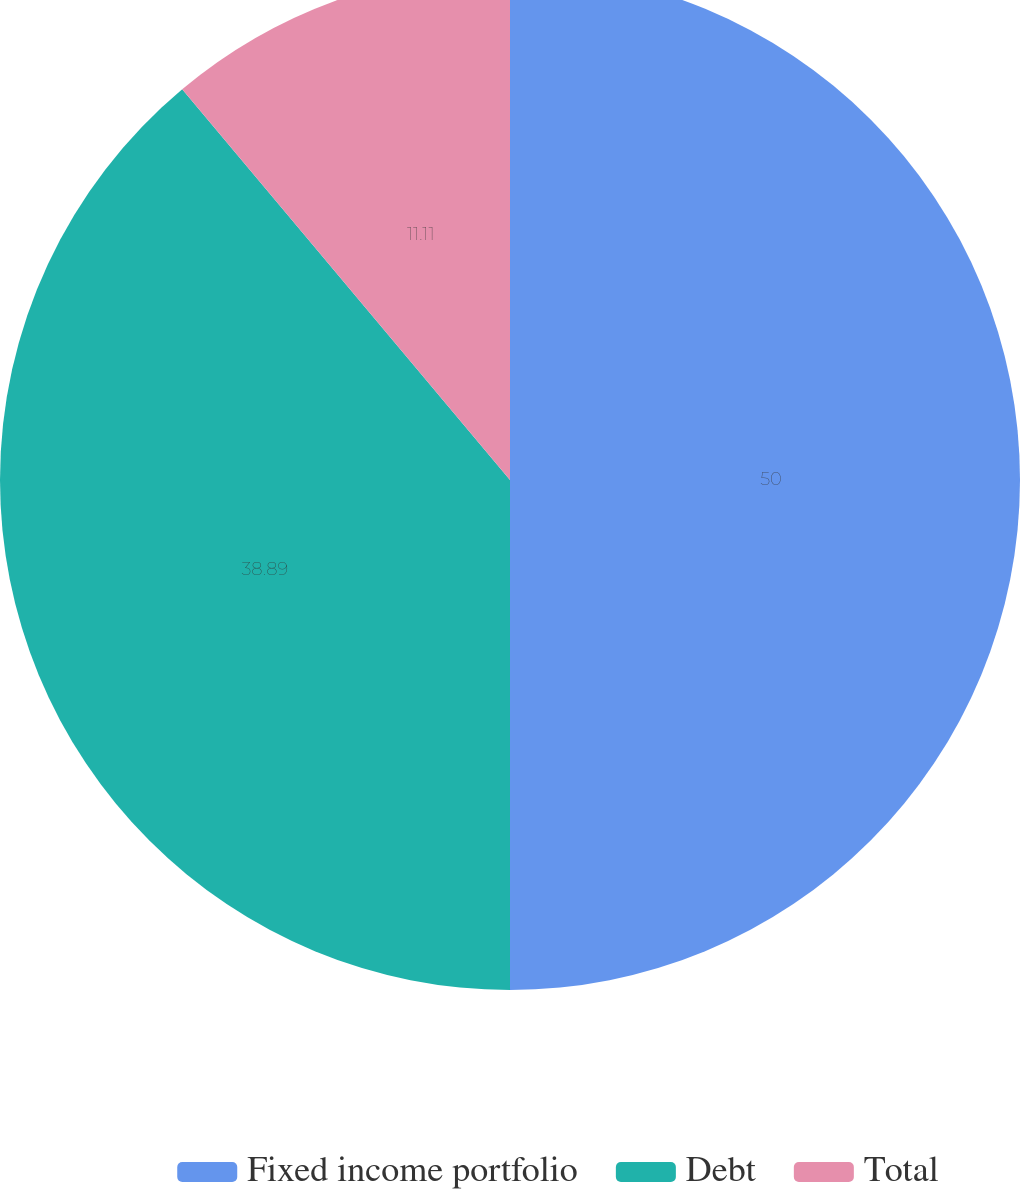<chart> <loc_0><loc_0><loc_500><loc_500><pie_chart><fcel>Fixed income portfolio<fcel>Debt<fcel>Total<nl><fcel>50.0%<fcel>38.89%<fcel>11.11%<nl></chart> 